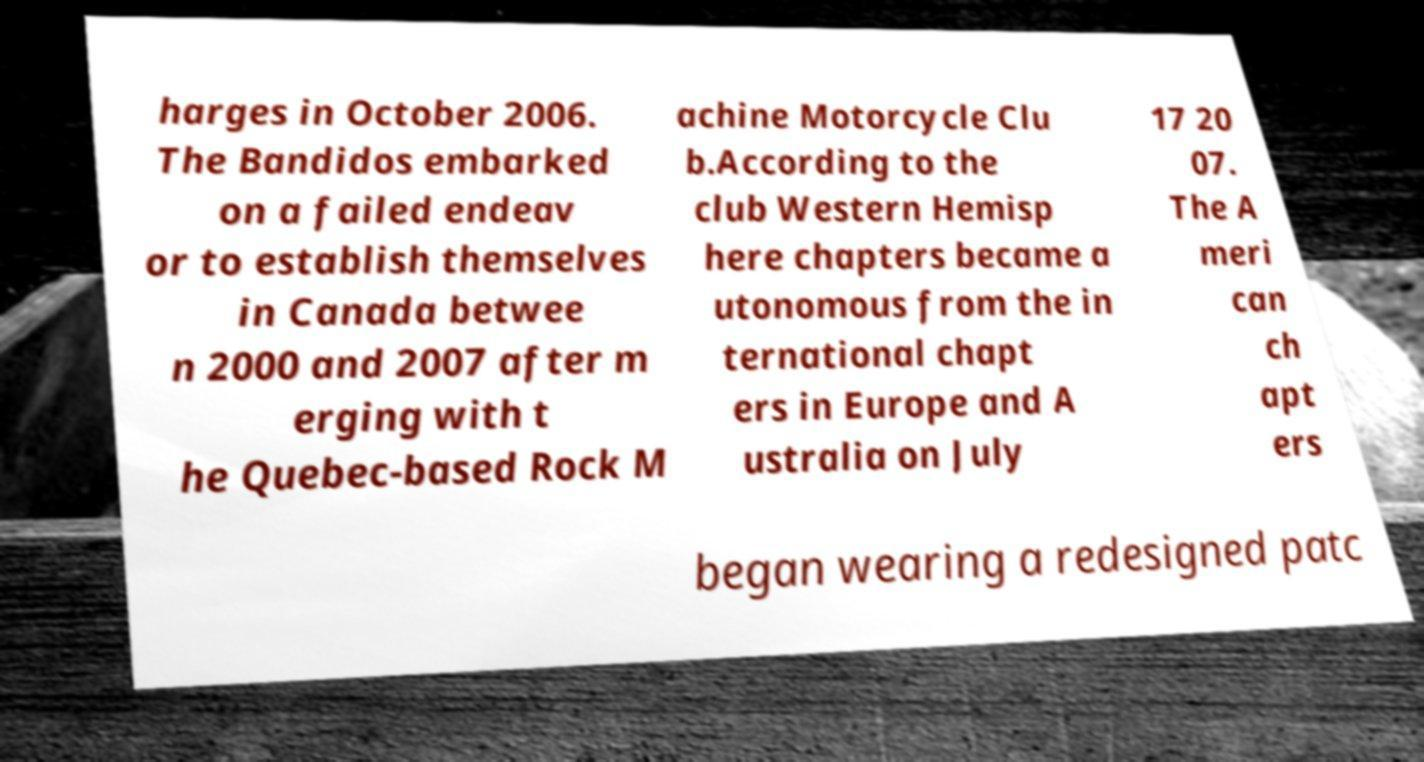For documentation purposes, I need the text within this image transcribed. Could you provide that? harges in October 2006. The Bandidos embarked on a failed endeav or to establish themselves in Canada betwee n 2000 and 2007 after m erging with t he Quebec-based Rock M achine Motorcycle Clu b.According to the club Western Hemisp here chapters became a utonomous from the in ternational chapt ers in Europe and A ustralia on July 17 20 07. The A meri can ch apt ers began wearing a redesigned patc 